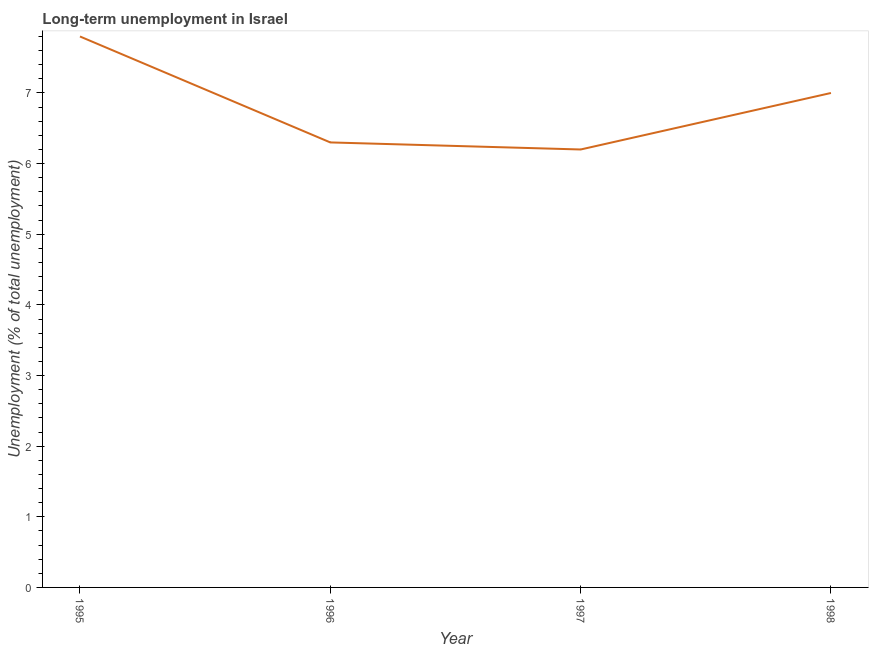What is the long-term unemployment in 1995?
Keep it short and to the point. 7.8. Across all years, what is the maximum long-term unemployment?
Provide a short and direct response. 7.8. Across all years, what is the minimum long-term unemployment?
Your answer should be very brief. 6.2. In which year was the long-term unemployment maximum?
Offer a very short reply. 1995. In which year was the long-term unemployment minimum?
Ensure brevity in your answer.  1997. What is the sum of the long-term unemployment?
Offer a terse response. 27.3. What is the difference between the long-term unemployment in 1996 and 1998?
Your answer should be compact. -0.7. What is the average long-term unemployment per year?
Ensure brevity in your answer.  6.83. What is the median long-term unemployment?
Your response must be concise. 6.65. In how many years, is the long-term unemployment greater than 1.8 %?
Give a very brief answer. 4. What is the ratio of the long-term unemployment in 1995 to that in 1996?
Offer a terse response. 1.24. Is the long-term unemployment in 1996 less than that in 1997?
Offer a very short reply. No. Is the difference between the long-term unemployment in 1996 and 1997 greater than the difference between any two years?
Provide a short and direct response. No. What is the difference between the highest and the second highest long-term unemployment?
Provide a succinct answer. 0.8. What is the difference between the highest and the lowest long-term unemployment?
Your response must be concise. 1.6. How many years are there in the graph?
Provide a short and direct response. 4. What is the difference between two consecutive major ticks on the Y-axis?
Make the answer very short. 1. Are the values on the major ticks of Y-axis written in scientific E-notation?
Offer a terse response. No. What is the title of the graph?
Keep it short and to the point. Long-term unemployment in Israel. What is the label or title of the X-axis?
Provide a short and direct response. Year. What is the label or title of the Y-axis?
Provide a short and direct response. Unemployment (% of total unemployment). What is the Unemployment (% of total unemployment) in 1995?
Ensure brevity in your answer.  7.8. What is the Unemployment (% of total unemployment) of 1996?
Provide a succinct answer. 6.3. What is the Unemployment (% of total unemployment) of 1997?
Give a very brief answer. 6.2. What is the difference between the Unemployment (% of total unemployment) in 1996 and 1997?
Keep it short and to the point. 0.1. What is the difference between the Unemployment (% of total unemployment) in 1996 and 1998?
Make the answer very short. -0.7. What is the difference between the Unemployment (% of total unemployment) in 1997 and 1998?
Make the answer very short. -0.8. What is the ratio of the Unemployment (% of total unemployment) in 1995 to that in 1996?
Give a very brief answer. 1.24. What is the ratio of the Unemployment (% of total unemployment) in 1995 to that in 1997?
Give a very brief answer. 1.26. What is the ratio of the Unemployment (% of total unemployment) in 1995 to that in 1998?
Provide a short and direct response. 1.11. What is the ratio of the Unemployment (% of total unemployment) in 1996 to that in 1997?
Give a very brief answer. 1.02. What is the ratio of the Unemployment (% of total unemployment) in 1996 to that in 1998?
Offer a terse response. 0.9. What is the ratio of the Unemployment (% of total unemployment) in 1997 to that in 1998?
Make the answer very short. 0.89. 